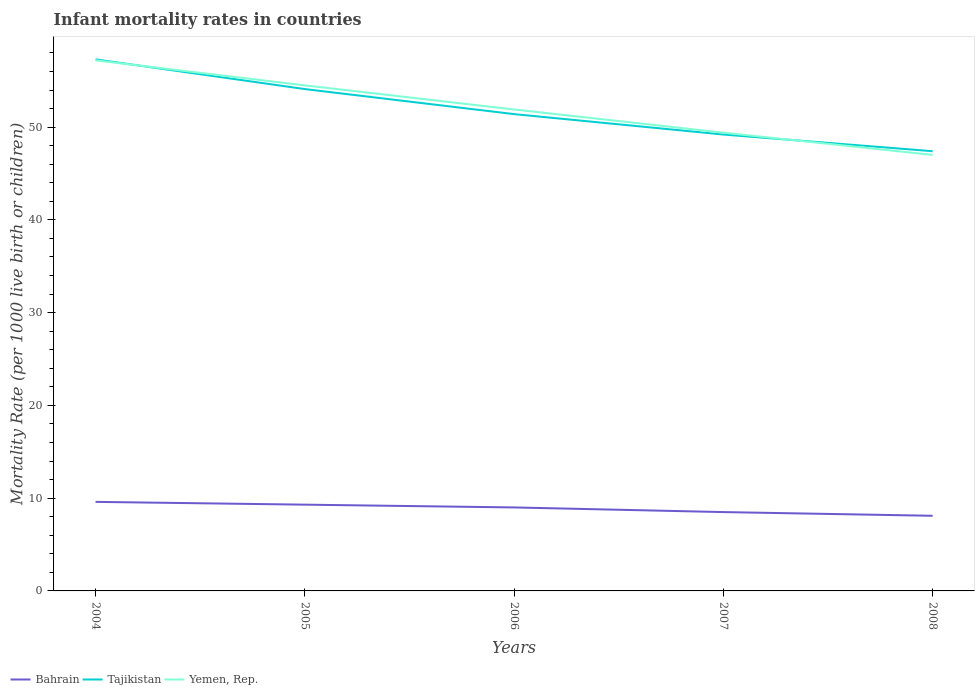Does the line corresponding to Yemen, Rep. intersect with the line corresponding to Tajikistan?
Provide a short and direct response. Yes. Is the number of lines equal to the number of legend labels?
Your answer should be very brief. Yes. Across all years, what is the maximum infant mortality rate in Tajikistan?
Your answer should be compact. 47.4. In which year was the infant mortality rate in Tajikistan maximum?
Provide a succinct answer. 2008. What is the total infant mortality rate in Bahrain in the graph?
Your answer should be very brief. 0.8. What is the difference between the highest and the second highest infant mortality rate in Yemen, Rep.?
Make the answer very short. 10.2. What is the difference between the highest and the lowest infant mortality rate in Tajikistan?
Provide a succinct answer. 2. Is the infant mortality rate in Bahrain strictly greater than the infant mortality rate in Tajikistan over the years?
Your answer should be compact. Yes. How many lines are there?
Make the answer very short. 3. How many years are there in the graph?
Provide a succinct answer. 5. Are the values on the major ticks of Y-axis written in scientific E-notation?
Make the answer very short. No. Does the graph contain grids?
Your answer should be very brief. No. Where does the legend appear in the graph?
Offer a terse response. Bottom left. How many legend labels are there?
Ensure brevity in your answer.  3. How are the legend labels stacked?
Make the answer very short. Horizontal. What is the title of the graph?
Keep it short and to the point. Infant mortality rates in countries. Does "Cote d'Ivoire" appear as one of the legend labels in the graph?
Keep it short and to the point. No. What is the label or title of the Y-axis?
Ensure brevity in your answer.  Mortality Rate (per 1000 live birth or children). What is the Mortality Rate (per 1000 live birth or children) of Bahrain in 2004?
Keep it short and to the point. 9.6. What is the Mortality Rate (per 1000 live birth or children) of Tajikistan in 2004?
Keep it short and to the point. 57.3. What is the Mortality Rate (per 1000 live birth or children) of Yemen, Rep. in 2004?
Your response must be concise. 57.2. What is the Mortality Rate (per 1000 live birth or children) of Tajikistan in 2005?
Provide a short and direct response. 54.1. What is the Mortality Rate (per 1000 live birth or children) in Yemen, Rep. in 2005?
Provide a succinct answer. 54.5. What is the Mortality Rate (per 1000 live birth or children) in Bahrain in 2006?
Offer a terse response. 9. What is the Mortality Rate (per 1000 live birth or children) of Tajikistan in 2006?
Your response must be concise. 51.4. What is the Mortality Rate (per 1000 live birth or children) in Yemen, Rep. in 2006?
Keep it short and to the point. 51.9. What is the Mortality Rate (per 1000 live birth or children) of Bahrain in 2007?
Your answer should be compact. 8.5. What is the Mortality Rate (per 1000 live birth or children) of Tajikistan in 2007?
Your answer should be compact. 49.2. What is the Mortality Rate (per 1000 live birth or children) of Yemen, Rep. in 2007?
Your answer should be compact. 49.4. What is the Mortality Rate (per 1000 live birth or children) of Tajikistan in 2008?
Offer a terse response. 47.4. Across all years, what is the maximum Mortality Rate (per 1000 live birth or children) in Tajikistan?
Your response must be concise. 57.3. Across all years, what is the maximum Mortality Rate (per 1000 live birth or children) in Yemen, Rep.?
Provide a succinct answer. 57.2. Across all years, what is the minimum Mortality Rate (per 1000 live birth or children) of Bahrain?
Offer a terse response. 8.1. Across all years, what is the minimum Mortality Rate (per 1000 live birth or children) in Tajikistan?
Provide a succinct answer. 47.4. What is the total Mortality Rate (per 1000 live birth or children) of Bahrain in the graph?
Offer a terse response. 44.5. What is the total Mortality Rate (per 1000 live birth or children) of Tajikistan in the graph?
Provide a succinct answer. 259.4. What is the total Mortality Rate (per 1000 live birth or children) in Yemen, Rep. in the graph?
Your response must be concise. 260. What is the difference between the Mortality Rate (per 1000 live birth or children) in Bahrain in 2004 and that in 2005?
Keep it short and to the point. 0.3. What is the difference between the Mortality Rate (per 1000 live birth or children) in Bahrain in 2004 and that in 2006?
Your response must be concise. 0.6. What is the difference between the Mortality Rate (per 1000 live birth or children) in Yemen, Rep. in 2004 and that in 2006?
Provide a succinct answer. 5.3. What is the difference between the Mortality Rate (per 1000 live birth or children) in Tajikistan in 2004 and that in 2007?
Provide a succinct answer. 8.1. What is the difference between the Mortality Rate (per 1000 live birth or children) of Tajikistan in 2004 and that in 2008?
Your response must be concise. 9.9. What is the difference between the Mortality Rate (per 1000 live birth or children) of Bahrain in 2005 and that in 2006?
Your answer should be compact. 0.3. What is the difference between the Mortality Rate (per 1000 live birth or children) of Tajikistan in 2005 and that in 2006?
Offer a terse response. 2.7. What is the difference between the Mortality Rate (per 1000 live birth or children) of Yemen, Rep. in 2005 and that in 2006?
Give a very brief answer. 2.6. What is the difference between the Mortality Rate (per 1000 live birth or children) of Yemen, Rep. in 2005 and that in 2007?
Provide a short and direct response. 5.1. What is the difference between the Mortality Rate (per 1000 live birth or children) of Bahrain in 2005 and that in 2008?
Make the answer very short. 1.2. What is the difference between the Mortality Rate (per 1000 live birth or children) in Tajikistan in 2006 and that in 2008?
Offer a terse response. 4. What is the difference between the Mortality Rate (per 1000 live birth or children) of Bahrain in 2007 and that in 2008?
Provide a short and direct response. 0.4. What is the difference between the Mortality Rate (per 1000 live birth or children) of Tajikistan in 2007 and that in 2008?
Provide a short and direct response. 1.8. What is the difference between the Mortality Rate (per 1000 live birth or children) in Yemen, Rep. in 2007 and that in 2008?
Make the answer very short. 2.4. What is the difference between the Mortality Rate (per 1000 live birth or children) of Bahrain in 2004 and the Mortality Rate (per 1000 live birth or children) of Tajikistan in 2005?
Give a very brief answer. -44.5. What is the difference between the Mortality Rate (per 1000 live birth or children) of Bahrain in 2004 and the Mortality Rate (per 1000 live birth or children) of Yemen, Rep. in 2005?
Your answer should be compact. -44.9. What is the difference between the Mortality Rate (per 1000 live birth or children) of Tajikistan in 2004 and the Mortality Rate (per 1000 live birth or children) of Yemen, Rep. in 2005?
Make the answer very short. 2.8. What is the difference between the Mortality Rate (per 1000 live birth or children) in Bahrain in 2004 and the Mortality Rate (per 1000 live birth or children) in Tajikistan in 2006?
Make the answer very short. -41.8. What is the difference between the Mortality Rate (per 1000 live birth or children) in Bahrain in 2004 and the Mortality Rate (per 1000 live birth or children) in Yemen, Rep. in 2006?
Offer a very short reply. -42.3. What is the difference between the Mortality Rate (per 1000 live birth or children) in Tajikistan in 2004 and the Mortality Rate (per 1000 live birth or children) in Yemen, Rep. in 2006?
Your response must be concise. 5.4. What is the difference between the Mortality Rate (per 1000 live birth or children) of Bahrain in 2004 and the Mortality Rate (per 1000 live birth or children) of Tajikistan in 2007?
Provide a short and direct response. -39.6. What is the difference between the Mortality Rate (per 1000 live birth or children) in Bahrain in 2004 and the Mortality Rate (per 1000 live birth or children) in Yemen, Rep. in 2007?
Offer a very short reply. -39.8. What is the difference between the Mortality Rate (per 1000 live birth or children) of Tajikistan in 2004 and the Mortality Rate (per 1000 live birth or children) of Yemen, Rep. in 2007?
Your answer should be very brief. 7.9. What is the difference between the Mortality Rate (per 1000 live birth or children) of Bahrain in 2004 and the Mortality Rate (per 1000 live birth or children) of Tajikistan in 2008?
Your answer should be very brief. -37.8. What is the difference between the Mortality Rate (per 1000 live birth or children) of Bahrain in 2004 and the Mortality Rate (per 1000 live birth or children) of Yemen, Rep. in 2008?
Provide a short and direct response. -37.4. What is the difference between the Mortality Rate (per 1000 live birth or children) of Bahrain in 2005 and the Mortality Rate (per 1000 live birth or children) of Tajikistan in 2006?
Offer a terse response. -42.1. What is the difference between the Mortality Rate (per 1000 live birth or children) of Bahrain in 2005 and the Mortality Rate (per 1000 live birth or children) of Yemen, Rep. in 2006?
Keep it short and to the point. -42.6. What is the difference between the Mortality Rate (per 1000 live birth or children) of Bahrain in 2005 and the Mortality Rate (per 1000 live birth or children) of Tajikistan in 2007?
Keep it short and to the point. -39.9. What is the difference between the Mortality Rate (per 1000 live birth or children) of Bahrain in 2005 and the Mortality Rate (per 1000 live birth or children) of Yemen, Rep. in 2007?
Provide a succinct answer. -40.1. What is the difference between the Mortality Rate (per 1000 live birth or children) in Tajikistan in 2005 and the Mortality Rate (per 1000 live birth or children) in Yemen, Rep. in 2007?
Provide a short and direct response. 4.7. What is the difference between the Mortality Rate (per 1000 live birth or children) in Bahrain in 2005 and the Mortality Rate (per 1000 live birth or children) in Tajikistan in 2008?
Provide a short and direct response. -38.1. What is the difference between the Mortality Rate (per 1000 live birth or children) in Bahrain in 2005 and the Mortality Rate (per 1000 live birth or children) in Yemen, Rep. in 2008?
Provide a succinct answer. -37.7. What is the difference between the Mortality Rate (per 1000 live birth or children) of Tajikistan in 2005 and the Mortality Rate (per 1000 live birth or children) of Yemen, Rep. in 2008?
Offer a terse response. 7.1. What is the difference between the Mortality Rate (per 1000 live birth or children) in Bahrain in 2006 and the Mortality Rate (per 1000 live birth or children) in Tajikistan in 2007?
Keep it short and to the point. -40.2. What is the difference between the Mortality Rate (per 1000 live birth or children) of Bahrain in 2006 and the Mortality Rate (per 1000 live birth or children) of Yemen, Rep. in 2007?
Ensure brevity in your answer.  -40.4. What is the difference between the Mortality Rate (per 1000 live birth or children) in Bahrain in 2006 and the Mortality Rate (per 1000 live birth or children) in Tajikistan in 2008?
Provide a succinct answer. -38.4. What is the difference between the Mortality Rate (per 1000 live birth or children) in Bahrain in 2006 and the Mortality Rate (per 1000 live birth or children) in Yemen, Rep. in 2008?
Provide a short and direct response. -38. What is the difference between the Mortality Rate (per 1000 live birth or children) of Bahrain in 2007 and the Mortality Rate (per 1000 live birth or children) of Tajikistan in 2008?
Provide a succinct answer. -38.9. What is the difference between the Mortality Rate (per 1000 live birth or children) of Bahrain in 2007 and the Mortality Rate (per 1000 live birth or children) of Yemen, Rep. in 2008?
Ensure brevity in your answer.  -38.5. What is the difference between the Mortality Rate (per 1000 live birth or children) of Tajikistan in 2007 and the Mortality Rate (per 1000 live birth or children) of Yemen, Rep. in 2008?
Provide a short and direct response. 2.2. What is the average Mortality Rate (per 1000 live birth or children) of Bahrain per year?
Your answer should be compact. 8.9. What is the average Mortality Rate (per 1000 live birth or children) in Tajikistan per year?
Your answer should be compact. 51.88. In the year 2004, what is the difference between the Mortality Rate (per 1000 live birth or children) of Bahrain and Mortality Rate (per 1000 live birth or children) of Tajikistan?
Give a very brief answer. -47.7. In the year 2004, what is the difference between the Mortality Rate (per 1000 live birth or children) in Bahrain and Mortality Rate (per 1000 live birth or children) in Yemen, Rep.?
Your response must be concise. -47.6. In the year 2005, what is the difference between the Mortality Rate (per 1000 live birth or children) in Bahrain and Mortality Rate (per 1000 live birth or children) in Tajikistan?
Keep it short and to the point. -44.8. In the year 2005, what is the difference between the Mortality Rate (per 1000 live birth or children) of Bahrain and Mortality Rate (per 1000 live birth or children) of Yemen, Rep.?
Keep it short and to the point. -45.2. In the year 2006, what is the difference between the Mortality Rate (per 1000 live birth or children) in Bahrain and Mortality Rate (per 1000 live birth or children) in Tajikistan?
Offer a terse response. -42.4. In the year 2006, what is the difference between the Mortality Rate (per 1000 live birth or children) in Bahrain and Mortality Rate (per 1000 live birth or children) in Yemen, Rep.?
Offer a terse response. -42.9. In the year 2006, what is the difference between the Mortality Rate (per 1000 live birth or children) in Tajikistan and Mortality Rate (per 1000 live birth or children) in Yemen, Rep.?
Make the answer very short. -0.5. In the year 2007, what is the difference between the Mortality Rate (per 1000 live birth or children) of Bahrain and Mortality Rate (per 1000 live birth or children) of Tajikistan?
Offer a terse response. -40.7. In the year 2007, what is the difference between the Mortality Rate (per 1000 live birth or children) of Bahrain and Mortality Rate (per 1000 live birth or children) of Yemen, Rep.?
Offer a terse response. -40.9. In the year 2008, what is the difference between the Mortality Rate (per 1000 live birth or children) in Bahrain and Mortality Rate (per 1000 live birth or children) in Tajikistan?
Your answer should be compact. -39.3. In the year 2008, what is the difference between the Mortality Rate (per 1000 live birth or children) in Bahrain and Mortality Rate (per 1000 live birth or children) in Yemen, Rep.?
Keep it short and to the point. -38.9. What is the ratio of the Mortality Rate (per 1000 live birth or children) of Bahrain in 2004 to that in 2005?
Your answer should be compact. 1.03. What is the ratio of the Mortality Rate (per 1000 live birth or children) of Tajikistan in 2004 to that in 2005?
Make the answer very short. 1.06. What is the ratio of the Mortality Rate (per 1000 live birth or children) in Yemen, Rep. in 2004 to that in 2005?
Ensure brevity in your answer.  1.05. What is the ratio of the Mortality Rate (per 1000 live birth or children) in Bahrain in 2004 to that in 2006?
Ensure brevity in your answer.  1.07. What is the ratio of the Mortality Rate (per 1000 live birth or children) of Tajikistan in 2004 to that in 2006?
Offer a very short reply. 1.11. What is the ratio of the Mortality Rate (per 1000 live birth or children) of Yemen, Rep. in 2004 to that in 2006?
Offer a very short reply. 1.1. What is the ratio of the Mortality Rate (per 1000 live birth or children) in Bahrain in 2004 to that in 2007?
Give a very brief answer. 1.13. What is the ratio of the Mortality Rate (per 1000 live birth or children) in Tajikistan in 2004 to that in 2007?
Your answer should be compact. 1.16. What is the ratio of the Mortality Rate (per 1000 live birth or children) in Yemen, Rep. in 2004 to that in 2007?
Offer a very short reply. 1.16. What is the ratio of the Mortality Rate (per 1000 live birth or children) in Bahrain in 2004 to that in 2008?
Provide a succinct answer. 1.19. What is the ratio of the Mortality Rate (per 1000 live birth or children) of Tajikistan in 2004 to that in 2008?
Make the answer very short. 1.21. What is the ratio of the Mortality Rate (per 1000 live birth or children) of Yemen, Rep. in 2004 to that in 2008?
Provide a succinct answer. 1.22. What is the ratio of the Mortality Rate (per 1000 live birth or children) in Bahrain in 2005 to that in 2006?
Your response must be concise. 1.03. What is the ratio of the Mortality Rate (per 1000 live birth or children) of Tajikistan in 2005 to that in 2006?
Give a very brief answer. 1.05. What is the ratio of the Mortality Rate (per 1000 live birth or children) of Yemen, Rep. in 2005 to that in 2006?
Give a very brief answer. 1.05. What is the ratio of the Mortality Rate (per 1000 live birth or children) in Bahrain in 2005 to that in 2007?
Give a very brief answer. 1.09. What is the ratio of the Mortality Rate (per 1000 live birth or children) in Tajikistan in 2005 to that in 2007?
Make the answer very short. 1.1. What is the ratio of the Mortality Rate (per 1000 live birth or children) in Yemen, Rep. in 2005 to that in 2007?
Offer a terse response. 1.1. What is the ratio of the Mortality Rate (per 1000 live birth or children) in Bahrain in 2005 to that in 2008?
Your answer should be compact. 1.15. What is the ratio of the Mortality Rate (per 1000 live birth or children) in Tajikistan in 2005 to that in 2008?
Keep it short and to the point. 1.14. What is the ratio of the Mortality Rate (per 1000 live birth or children) of Yemen, Rep. in 2005 to that in 2008?
Provide a short and direct response. 1.16. What is the ratio of the Mortality Rate (per 1000 live birth or children) in Bahrain in 2006 to that in 2007?
Give a very brief answer. 1.06. What is the ratio of the Mortality Rate (per 1000 live birth or children) of Tajikistan in 2006 to that in 2007?
Give a very brief answer. 1.04. What is the ratio of the Mortality Rate (per 1000 live birth or children) in Yemen, Rep. in 2006 to that in 2007?
Provide a short and direct response. 1.05. What is the ratio of the Mortality Rate (per 1000 live birth or children) of Bahrain in 2006 to that in 2008?
Give a very brief answer. 1.11. What is the ratio of the Mortality Rate (per 1000 live birth or children) in Tajikistan in 2006 to that in 2008?
Give a very brief answer. 1.08. What is the ratio of the Mortality Rate (per 1000 live birth or children) of Yemen, Rep. in 2006 to that in 2008?
Provide a succinct answer. 1.1. What is the ratio of the Mortality Rate (per 1000 live birth or children) of Bahrain in 2007 to that in 2008?
Your answer should be very brief. 1.05. What is the ratio of the Mortality Rate (per 1000 live birth or children) of Tajikistan in 2007 to that in 2008?
Make the answer very short. 1.04. What is the ratio of the Mortality Rate (per 1000 live birth or children) of Yemen, Rep. in 2007 to that in 2008?
Your answer should be compact. 1.05. What is the difference between the highest and the second highest Mortality Rate (per 1000 live birth or children) of Bahrain?
Provide a succinct answer. 0.3. What is the difference between the highest and the second highest Mortality Rate (per 1000 live birth or children) of Yemen, Rep.?
Give a very brief answer. 2.7. What is the difference between the highest and the lowest Mortality Rate (per 1000 live birth or children) of Tajikistan?
Your answer should be compact. 9.9. What is the difference between the highest and the lowest Mortality Rate (per 1000 live birth or children) in Yemen, Rep.?
Offer a very short reply. 10.2. 